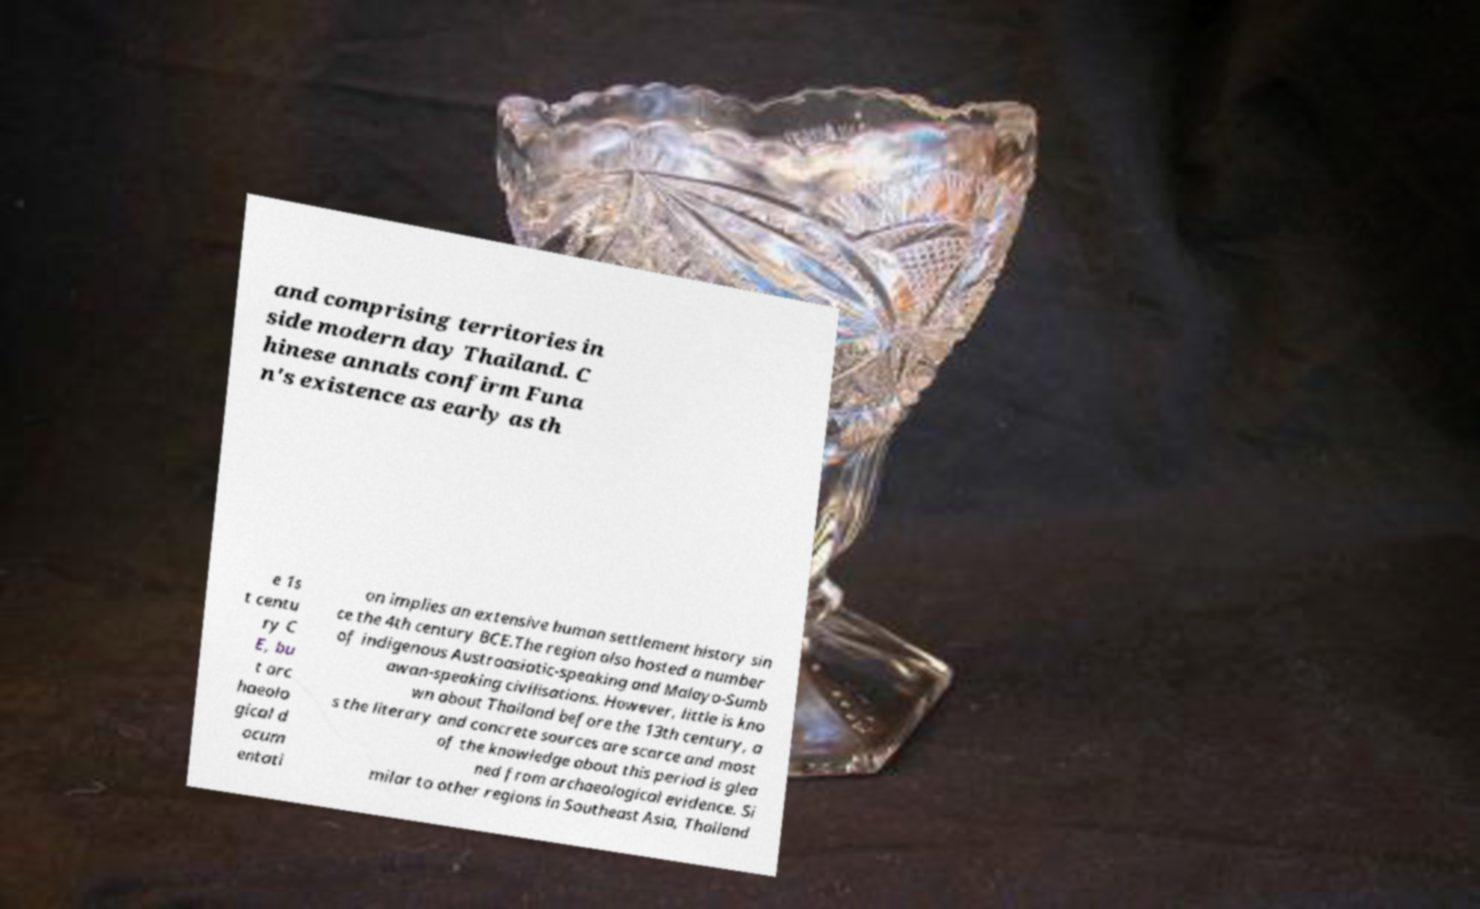Please identify and transcribe the text found in this image. and comprising territories in side modern day Thailand. C hinese annals confirm Funa n's existence as early as th e 1s t centu ry C E, bu t arc haeolo gical d ocum entati on implies an extensive human settlement history sin ce the 4th century BCE.The region also hosted a number of indigenous Austroasiatic-speaking and Malayo-Sumb awan-speaking civilisations. However, little is kno wn about Thailand before the 13th century, a s the literary and concrete sources are scarce and most of the knowledge about this period is glea ned from archaeological evidence. Si milar to other regions in Southeast Asia, Thailand 